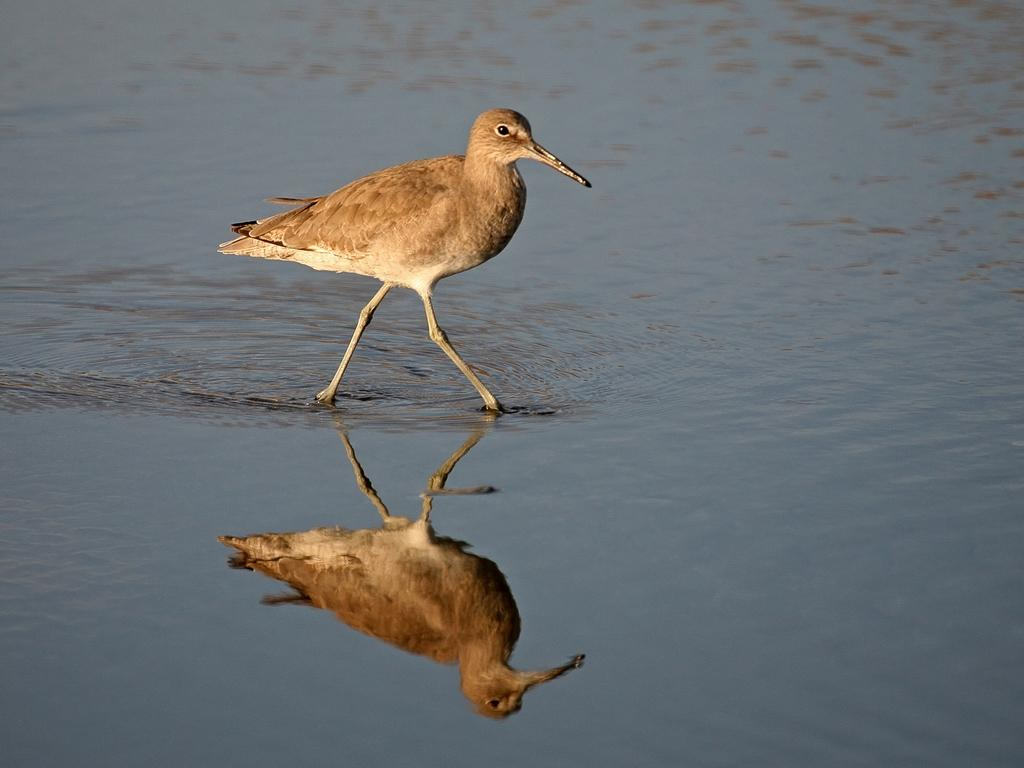What type of animal is in the image? There is a bird in the image. Where is the bird located in the image? The bird is standing in the water. What effect does the water have on the bird's appearance in the image? The water in the image reflects the bird. What type of pets are visible in the image? There are no pets visible in the image; it only features a bird standing in the water. 